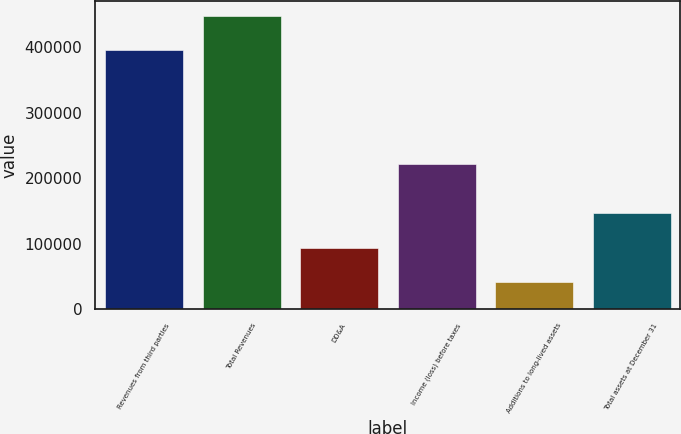Convert chart. <chart><loc_0><loc_0><loc_500><loc_500><bar_chart><fcel>Revenues from third parties<fcel>Total Revenues<fcel>DD&A<fcel>Income (loss) before taxes<fcel>Additions to long-lived assets<fcel>Total assets at December 31<nl><fcel>395353<fcel>447470<fcel>93086.1<fcel>220779<fcel>40969<fcel>146311<nl></chart> 